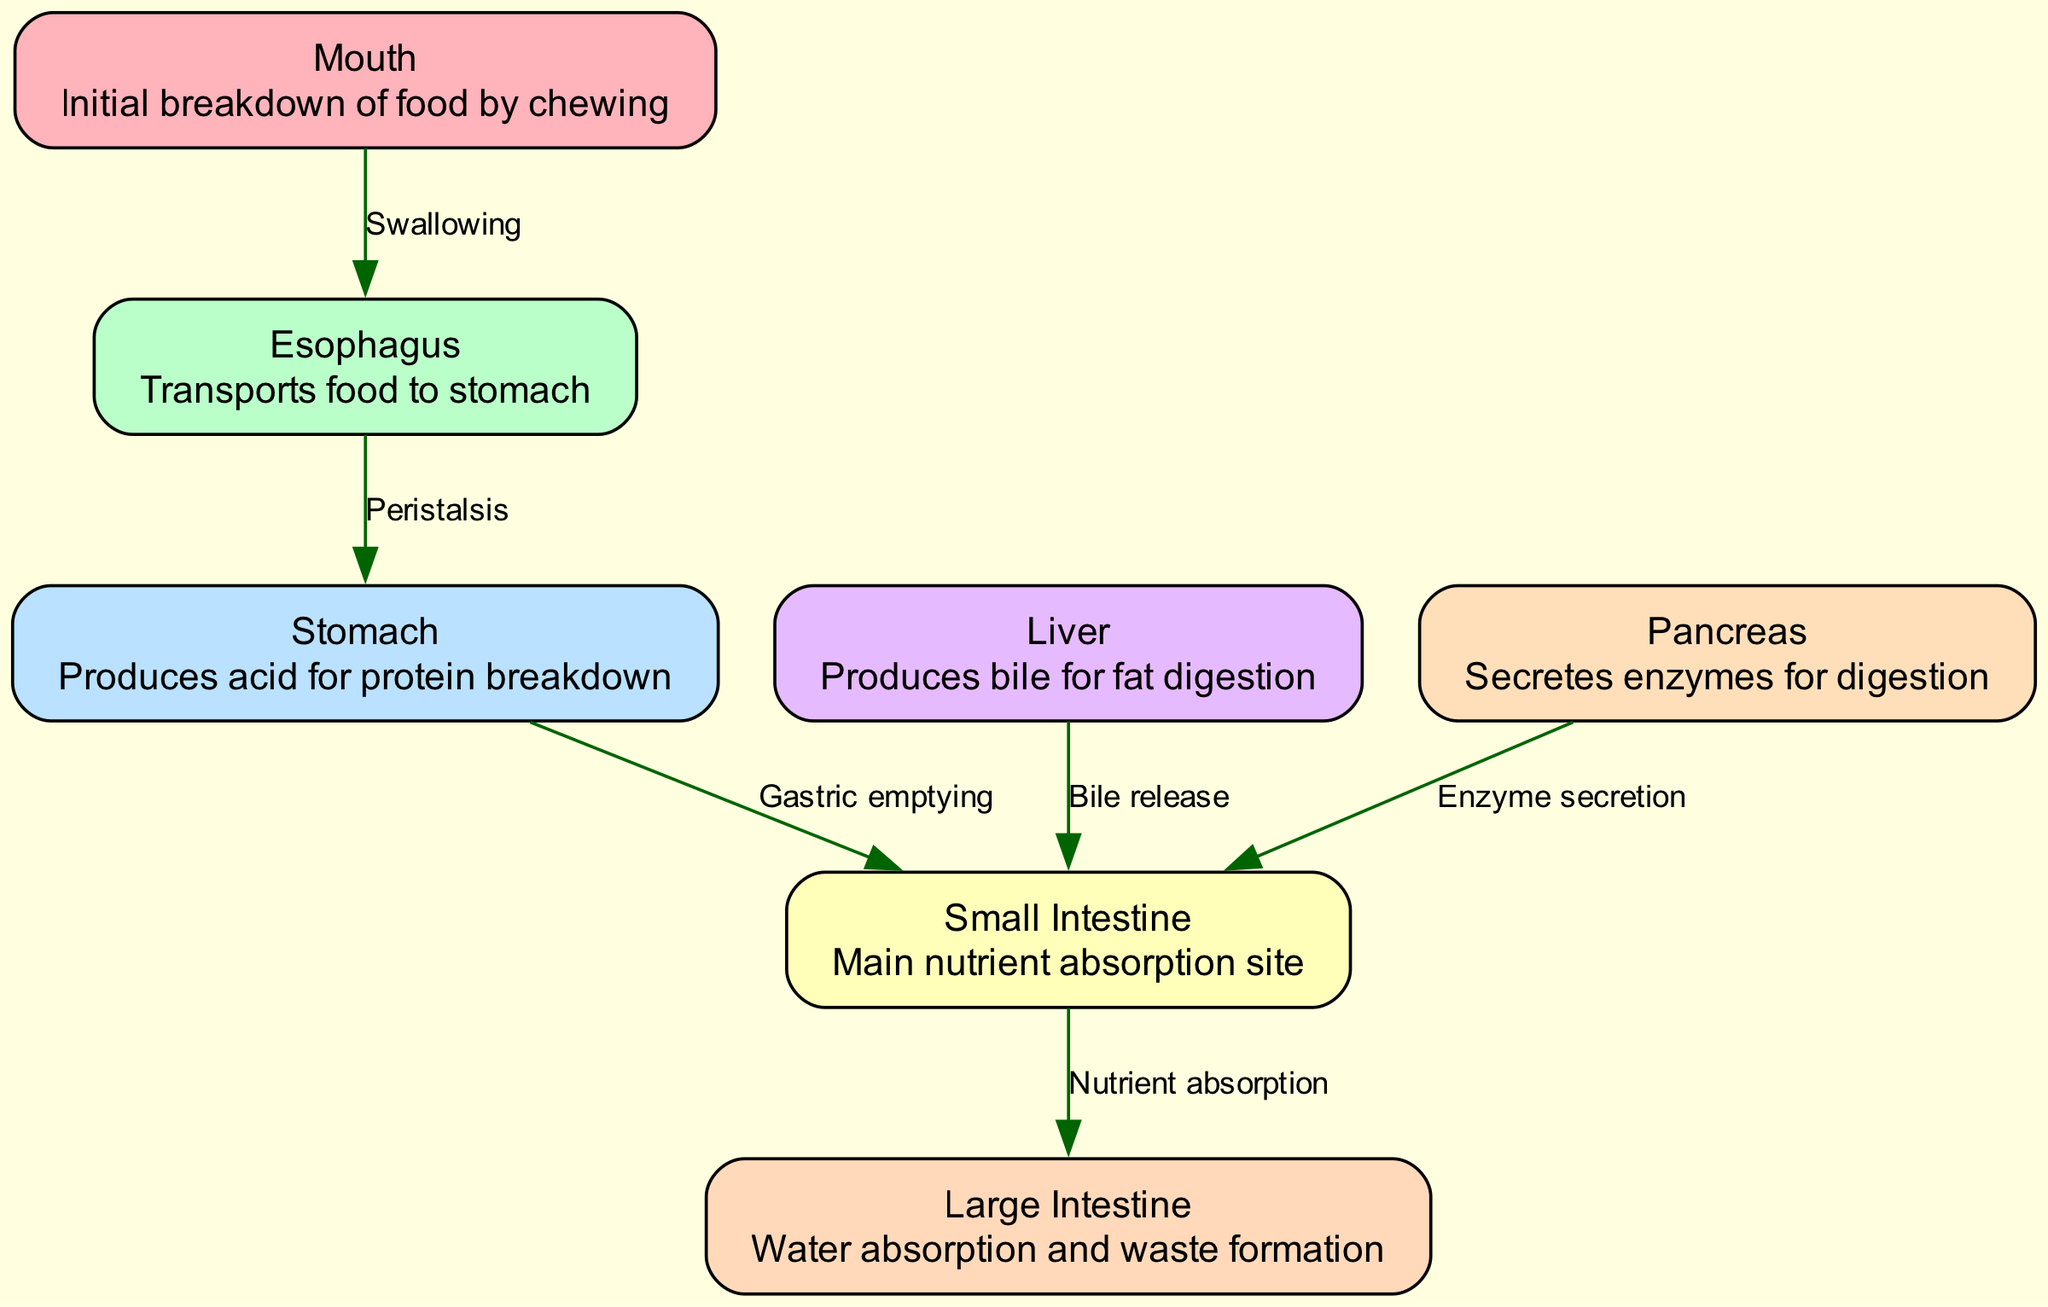What is the initial organ where food breakdown begins? The diagram labels the "Mouth" as the first organ involved in the digestive process, specifically stating that it is responsible for the initial breakdown of food by chewing.
Answer: Mouth How many nodes represent major organs in the digestive system? The diagram includes 7 nodes representing major organs: Mouth, Esophagus, Stomach, Small Intestine, Large Intestine, Liver, and Pancreas. Thus, the count is determined by simply listing these nodes.
Answer: 7 What process connects the mouth to the esophagus? The diagram indicates the flow from the Mouth to the Esophagus, labeled as "Swallowing," which directly describes the process involved in moving food from the mouth to the esophagus.
Answer: Swallowing Which organ is responsible for producing bile? According to the diagram, the "Liver" is annotated as the organ that produces bile needed for fat digestion, which plays a key role in the digestive system.
Answer: Liver What is the main function of the small intestine? The diagram explicitly labels the Small Intestine as the "Main nutrient absorption site," indicating its primary role in the digestion process.
Answer: Main nutrient absorption site What connects the stomach to the small intestine? In the diagram, the connection between the Stomach and the Small Intestine is labeled as "Gastric emptying," which describes the process through which digested food moves from the stomach to the small intestine.
Answer: Gastric emptying Which organ secretes enzymes for digestion, and where do they act? The diagram shows that the "Pancreas" secretes enzymes for digestion, which act in the Small Intestine as indicated by the edge leading from the pancreas to the small intestine.
Answer: Pancreas; Small Intestine What role does the large intestine play in digestion? The diagram notes that the Large Intestine is involved in "Water absorption and waste formation," indicating its function in reabsorbing water and preparing waste for excretion.
Answer: Water absorption and waste formation How does bile reach the small intestine from the liver? According to the diagram, bile reaches the small intestine from the liver through the process labeled as "Bile release," which indicates the mechanism of bile transport between these two organs.
Answer: Bile release 